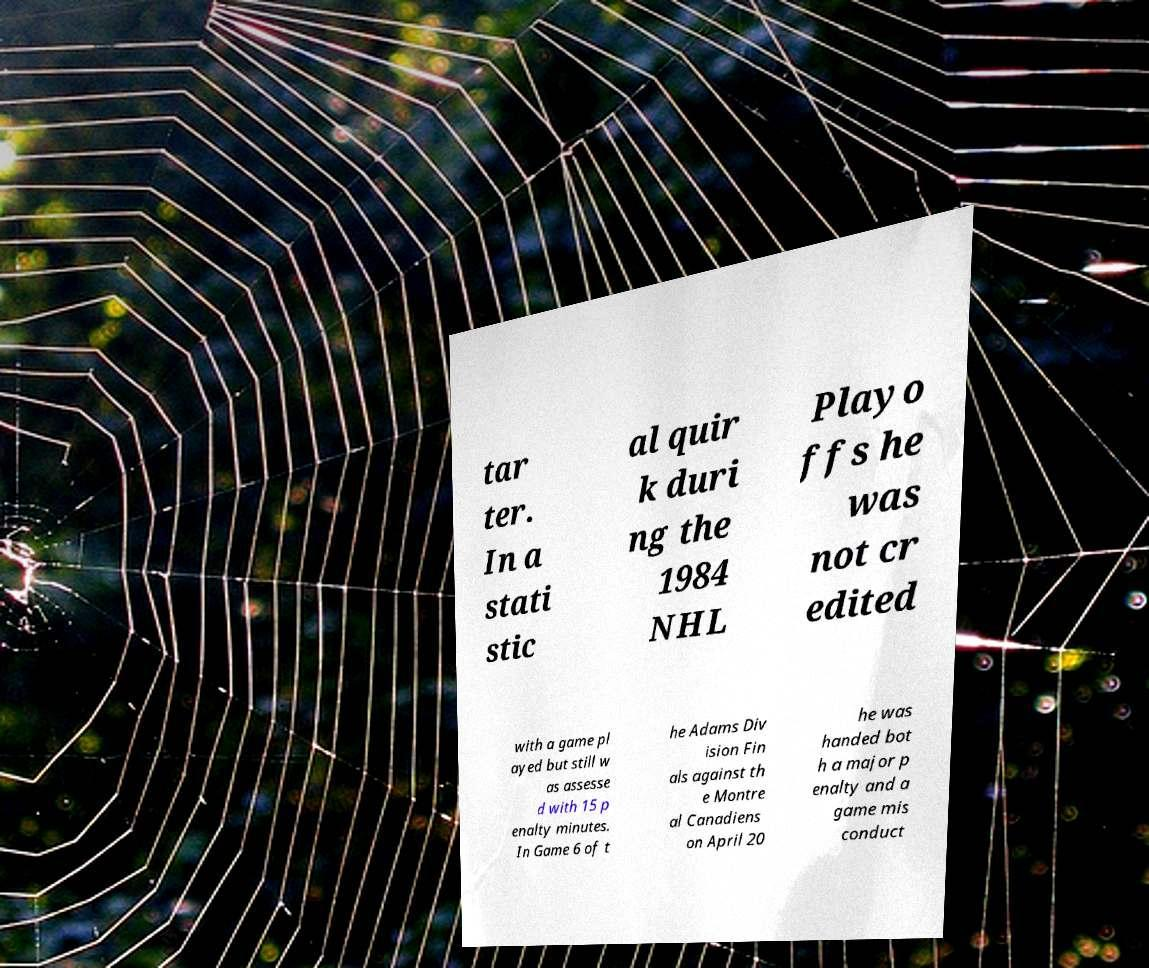I need the written content from this picture converted into text. Can you do that? tar ter. In a stati stic al quir k duri ng the 1984 NHL Playo ffs he was not cr edited with a game pl ayed but still w as assesse d with 15 p enalty minutes. In Game 6 of t he Adams Div ision Fin als against th e Montre al Canadiens on April 20 he was handed bot h a major p enalty and a game mis conduct 